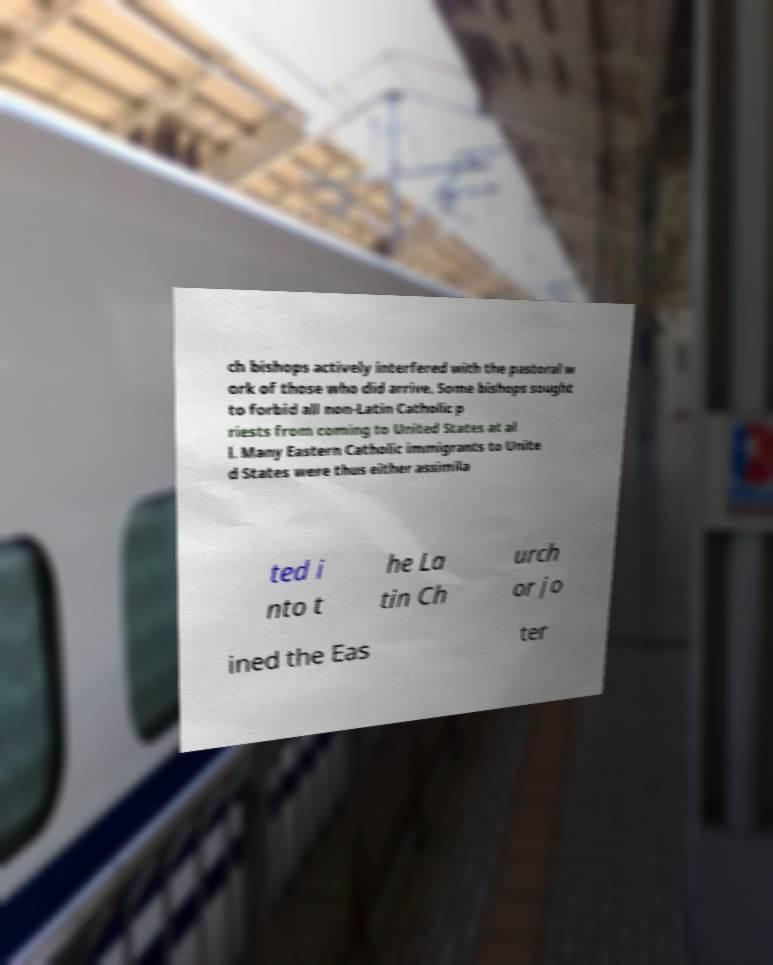Can you accurately transcribe the text from the provided image for me? ch bishops actively interfered with the pastoral w ork of those who did arrive. Some bishops sought to forbid all non-Latin Catholic p riests from coming to United States at al l. Many Eastern Catholic immigrants to Unite d States were thus either assimila ted i nto t he La tin Ch urch or jo ined the Eas ter 